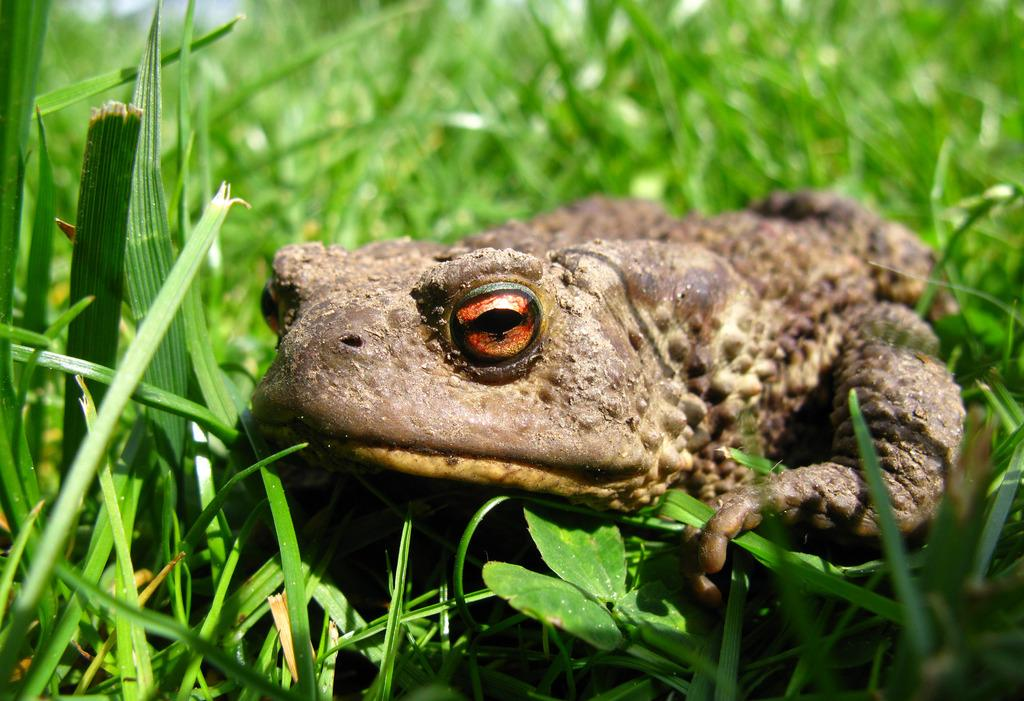What is the main subject in the center of the image? There is a frog in the center of the image. What type of environment is depicted in the image? The image contains grass, suggesting a natural setting. What year is the tent set up in the image? There is no tent present in the image, so it is not possible to determine the year. 